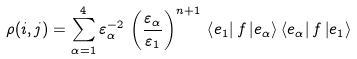Convert formula to latex. <formula><loc_0><loc_0><loc_500><loc_500>\rho ( i , j ) = \sum _ { \alpha = 1 } ^ { 4 } \varepsilon _ { \alpha } ^ { - 2 } \, \left ( \frac { \varepsilon _ { \alpha } } { \varepsilon _ { 1 } } \right ) ^ { n + 1 } \, \left \langle e _ { 1 } \right | f \left | e _ { \alpha } \right \rangle \left \langle e _ { \alpha } \right | f \left | e _ { 1 } \right \rangle</formula> 